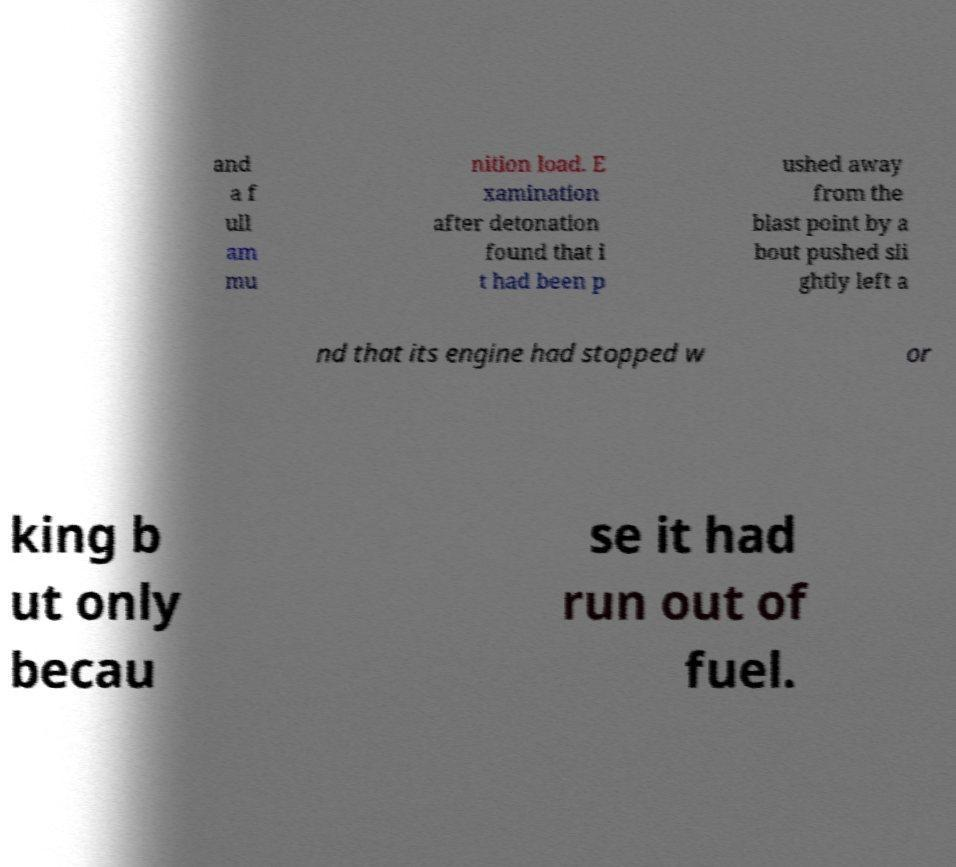Please identify and transcribe the text found in this image. and a f ull am mu nition load. E xamination after detonation found that i t had been p ushed away from the blast point by a bout pushed sli ghtly left a nd that its engine had stopped w or king b ut only becau se it had run out of fuel. 